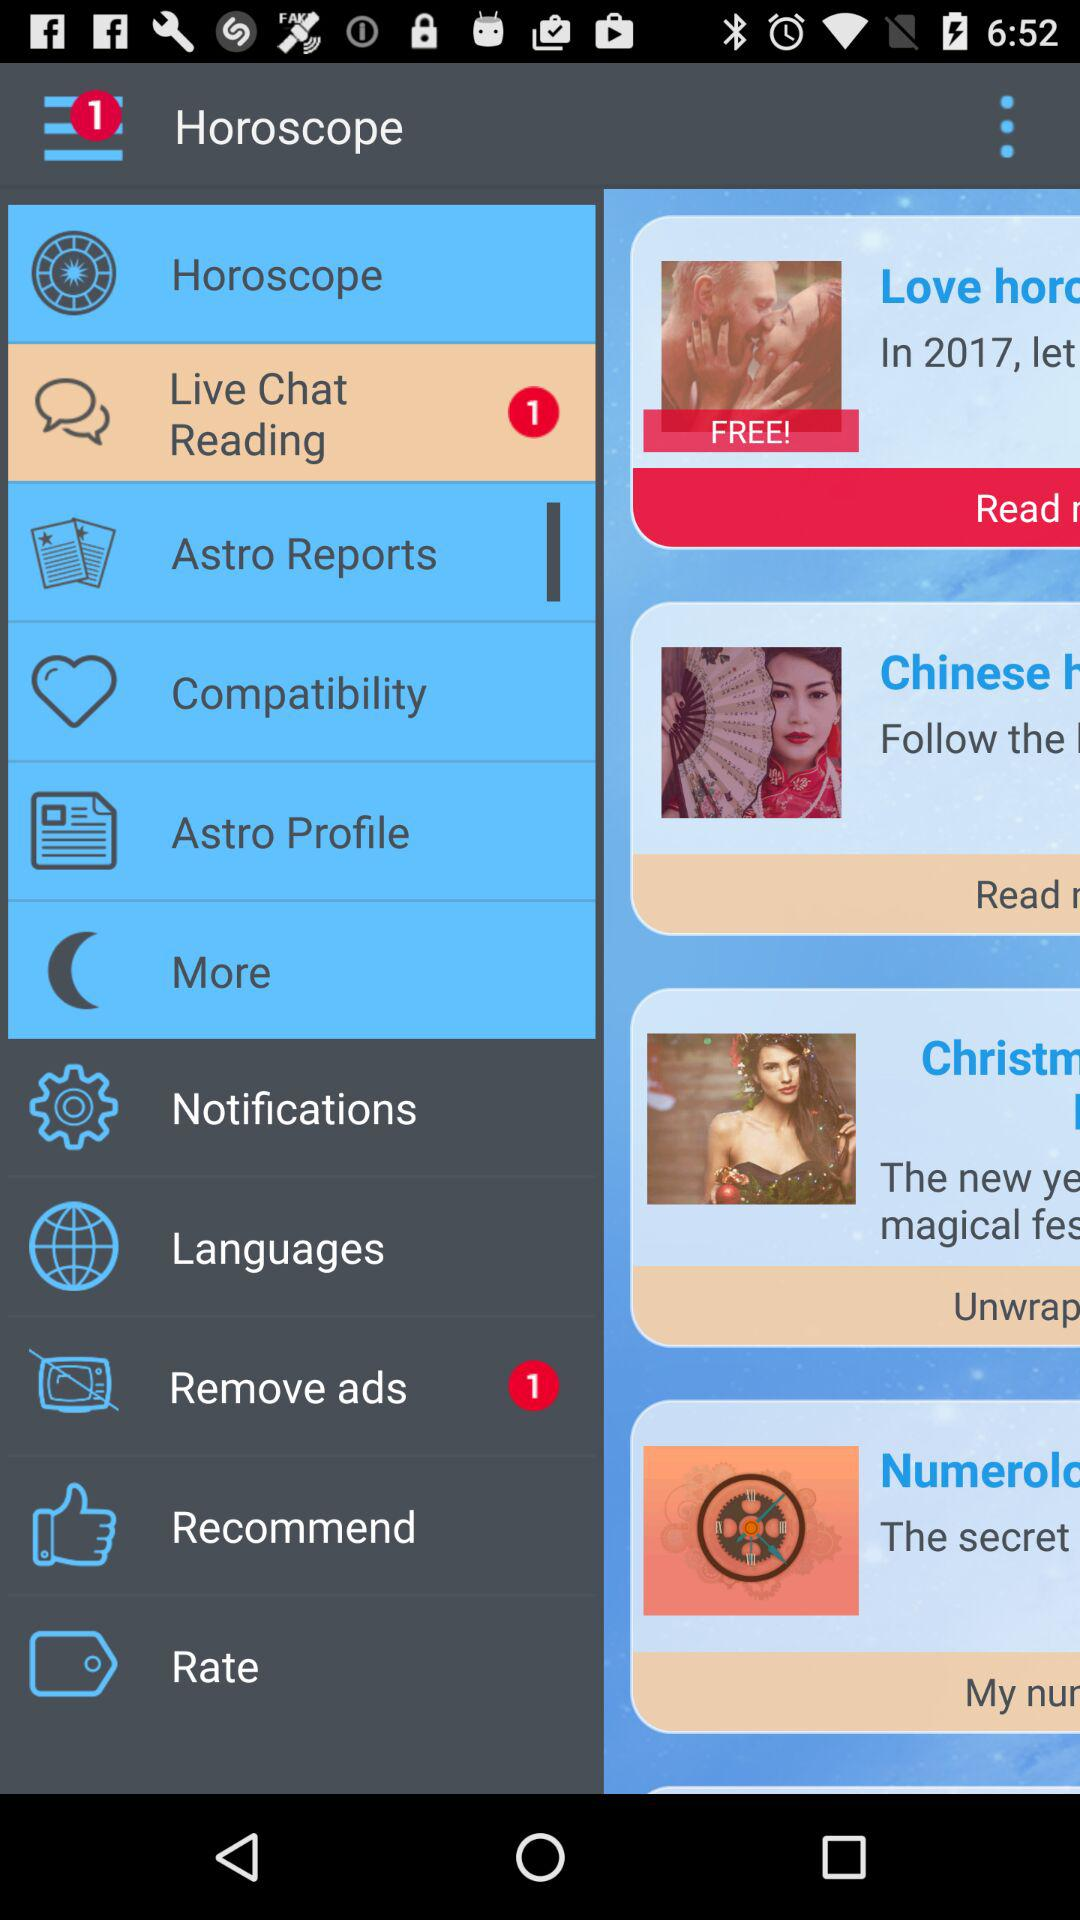How many chats are unread in "Live Chat Reading"? There is 1 unread chat. 